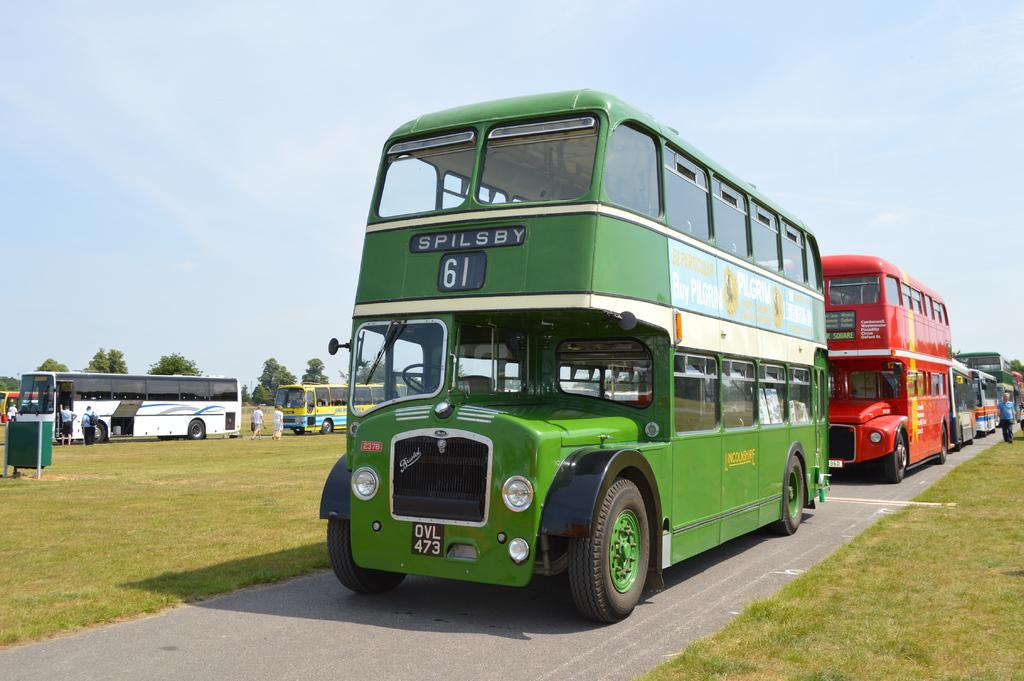<image>
Write a terse but informative summary of the picture. Spilsby 61 is the name and number of this public bus. 